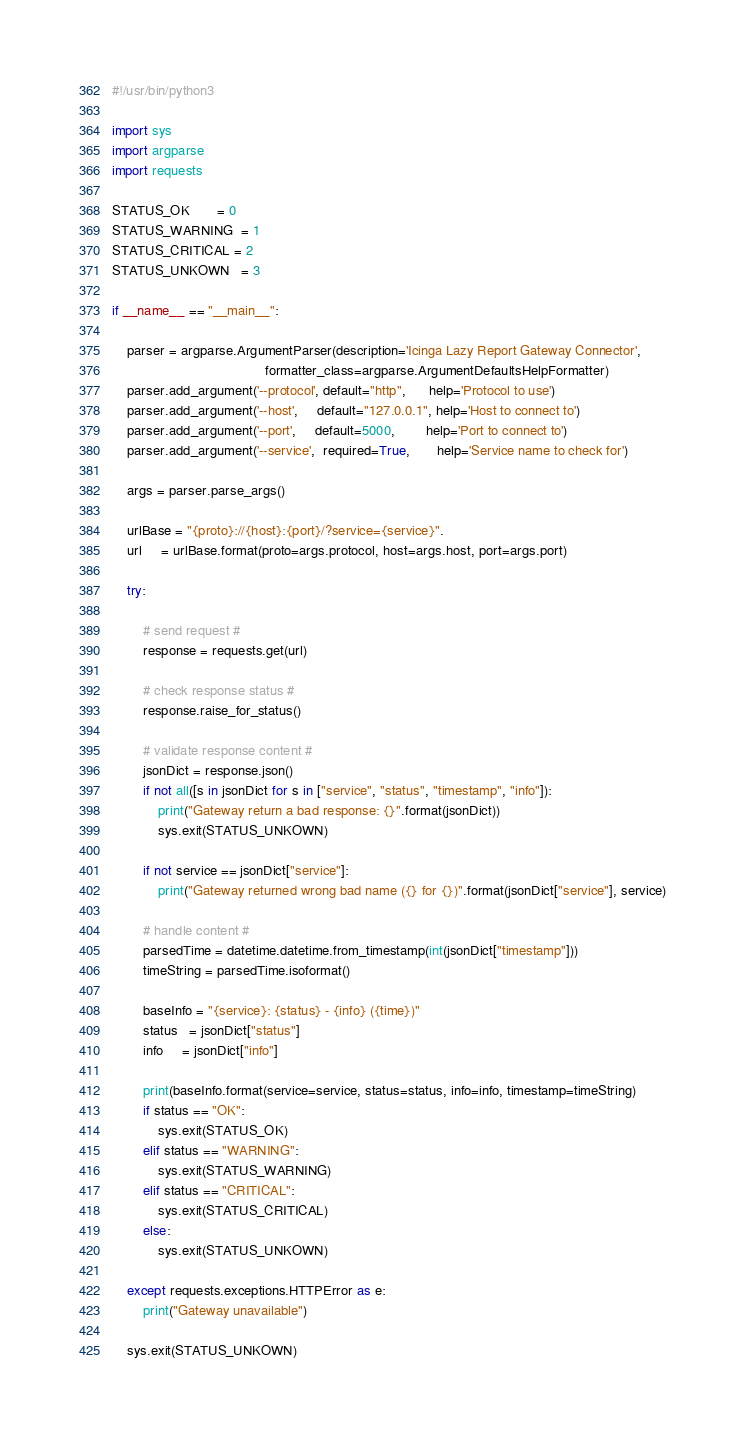Convert code to text. <code><loc_0><loc_0><loc_500><loc_500><_Python_>#!/usr/bin/python3

import sys
import argparse
import requests

STATUS_OK       = 0
STATUS_WARNING  = 1
STATUS_CRITICAL = 2
STATUS_UNKOWN   = 3

if __name__ == "__main__":

    parser = argparse.ArgumentParser(description='Icinga Lazy Report Gateway Connector', 
                                        formatter_class=argparse.ArgumentDefaultsHelpFormatter)
    parser.add_argument('--protocol', default="http",      help='Protocol to use')
    parser.add_argument('--host',     default="127.0.0.1", help='Host to connect to')
    parser.add_argument('--port',     default=5000,        help='Port to connect to')
    parser.add_argument('--service',  required=True,       help='Service name to check for')

    args = parser.parse_args()

    urlBase = "{proto}://{host}:{port}/?service={service}".
    url     = urlBase.format(proto=args.protocol, host=args.host, port=args.port)

    try:
        
        # send request #
        response = requests.get(url)

        # check response status #
        response.raise_for_status()

        # validate response content #
        jsonDict = response.json()
        if not all([s in jsonDict for s in ["service", "status", "timestamp", "info"]):
            print("Gateway return a bad response: {}".format(jsonDict))
            sys.exit(STATUS_UNKOWN)

        if not service == jsonDict["service"]:
            print("Gateway returned wrong bad name ({} for {})".format(jsonDict["service"], service)

        # handle content #
        parsedTime = datetime.datetime.from_timestamp(int(jsonDict["timestamp"]))
        timeString = parsedTime.isoformat()
       
        baseInfo = "{service}: {status} - {info} ({time})"
        status   = jsonDict["status"]
        info     = jsonDict["info"]

        print(baseInfo.format(service=service, status=status, info=info, timestamp=timeString)
        if status == "OK":
            sys.exit(STATUS_OK)
        elif status == "WARNING":
            sys.exit(STATUS_WARNING)
        elif status == "CRITICAL":
            sys.exit(STATUS_CRITICAL)
        else:
            sys.exit(STATUS_UNKOWN)

    except requests.exceptions.HTTPError as e:
        print("Gateway unavailable")

    sys.exit(STATUS_UNKOWN)
</code> 